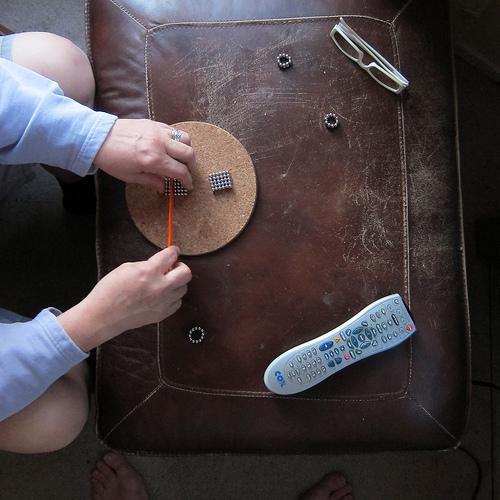How many people in the picture?
Give a very brief answer. 2. How many pairs of glasses?
Give a very brief answer. 1. 